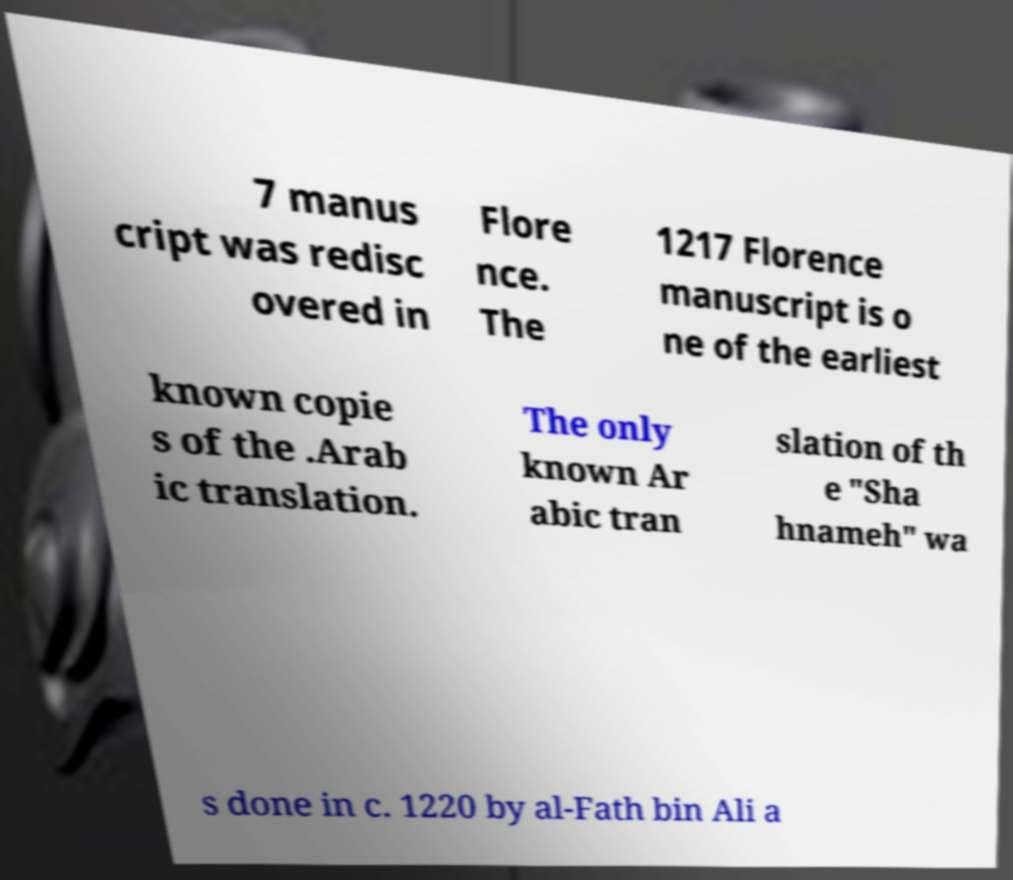What messages or text are displayed in this image? I need them in a readable, typed format. 7 manus cript was redisc overed in Flore nce. The 1217 Florence manuscript is o ne of the earliest known copie s of the .Arab ic translation. The only known Ar abic tran slation of th e "Sha hnameh" wa s done in c. 1220 by al-Fath bin Ali a 